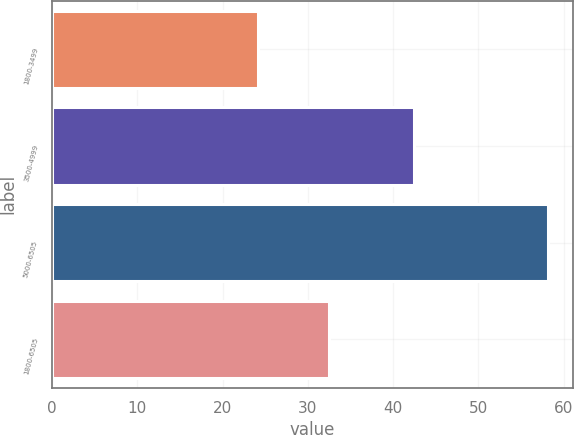<chart> <loc_0><loc_0><loc_500><loc_500><bar_chart><fcel>1800-3499<fcel>3500-4999<fcel>5000-6505<fcel>1800-6505<nl><fcel>24.1<fcel>42.42<fcel>58.19<fcel>32.52<nl></chart> 